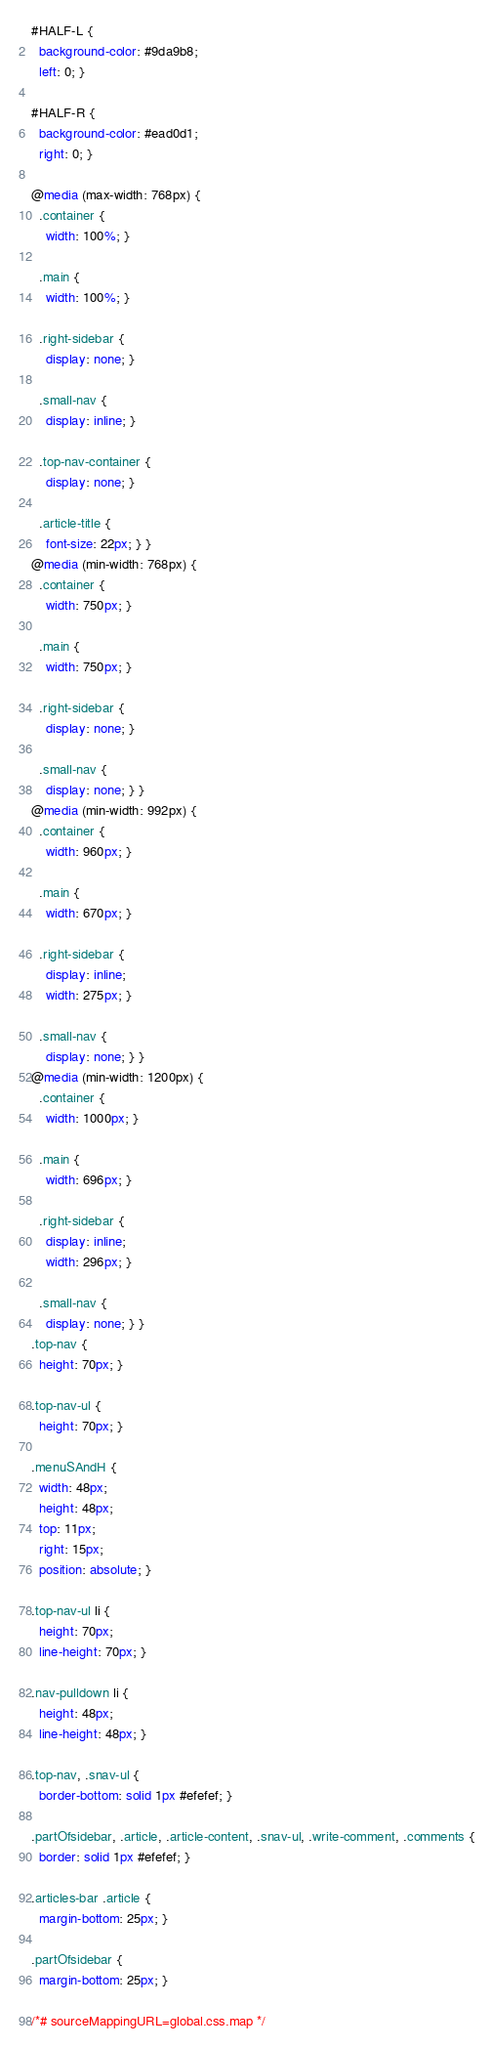<code> <loc_0><loc_0><loc_500><loc_500><_CSS_>#HALF-L {
  background-color: #9da9b8;
  left: 0; }

#HALF-R {
  background-color: #ead0d1;
  right: 0; }

@media (max-width: 768px) {
  .container {
    width: 100%; }

  .main {
    width: 100%; }

  .right-sidebar {
    display: none; }

  .small-nav {
    display: inline; }

  .top-nav-container {
    display: none; }

  .article-title {
    font-size: 22px; } }
@media (min-width: 768px) {
  .container {
    width: 750px; }

  .main {
    width: 750px; }

  .right-sidebar {
    display: none; }

  .small-nav {
    display: none; } }
@media (min-width: 992px) {
  .container {
    width: 960px; }

  .main {
    width: 670px; }

  .right-sidebar {
    display: inline;
    width: 275px; }

  .small-nav {
    display: none; } }
@media (min-width: 1200px) {
  .container {
    width: 1000px; }

  .main {
    width: 696px; }

  .right-sidebar {
    display: inline;
    width: 296px; }

  .small-nav {
    display: none; } }
.top-nav {
  height: 70px; }

.top-nav-ul {
  height: 70px; }

.menuSAndH {
  width: 48px;
  height: 48px;
  top: 11px;
  right: 15px;
  position: absolute; }

.top-nav-ul li {
  height: 70px;
  line-height: 70px; }

.nav-pulldown li {
  height: 48px;
  line-height: 48px; }

.top-nav, .snav-ul {
  border-bottom: solid 1px #efefef; }

.partOfsidebar, .article, .article-content, .snav-ul, .write-comment, .comments {
  border: solid 1px #efefef; }

.articles-bar .article {
  margin-bottom: 25px; }

.partOfsidebar {
  margin-bottom: 25px; }

/*# sourceMappingURL=global.css.map */
</code> 